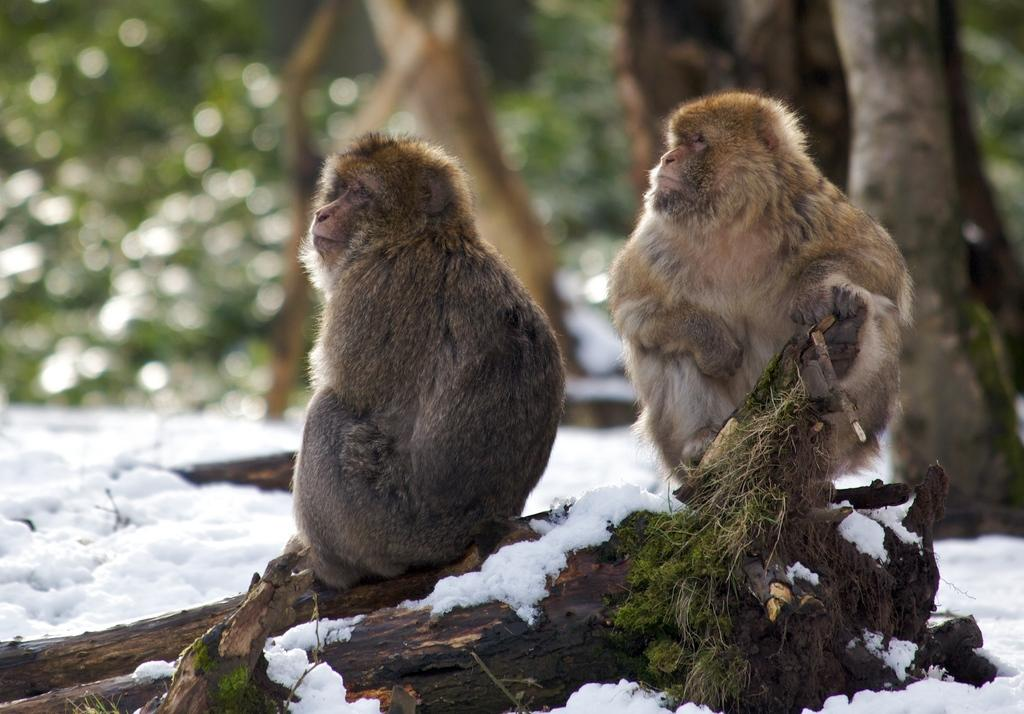How many monkeys are in the image? There are two monkeys in the image. What are the monkeys doing in the image? The monkeys are sitting on a stick. Where is the stick located in the image? The stick is on the ground. What is the weather like in the image? There is snow visible in the image, indicating a cold or wintery environment. What can be seen in the background of the image? There are trees in the background of the image. What type of cheese is being offered to the monkeys in the image? There is no cheese present in the image; the monkeys are sitting on a stick. Who is the representative of the monkeys in the image? There is no representative present in the image; the focus is on the two monkeys themselves. 